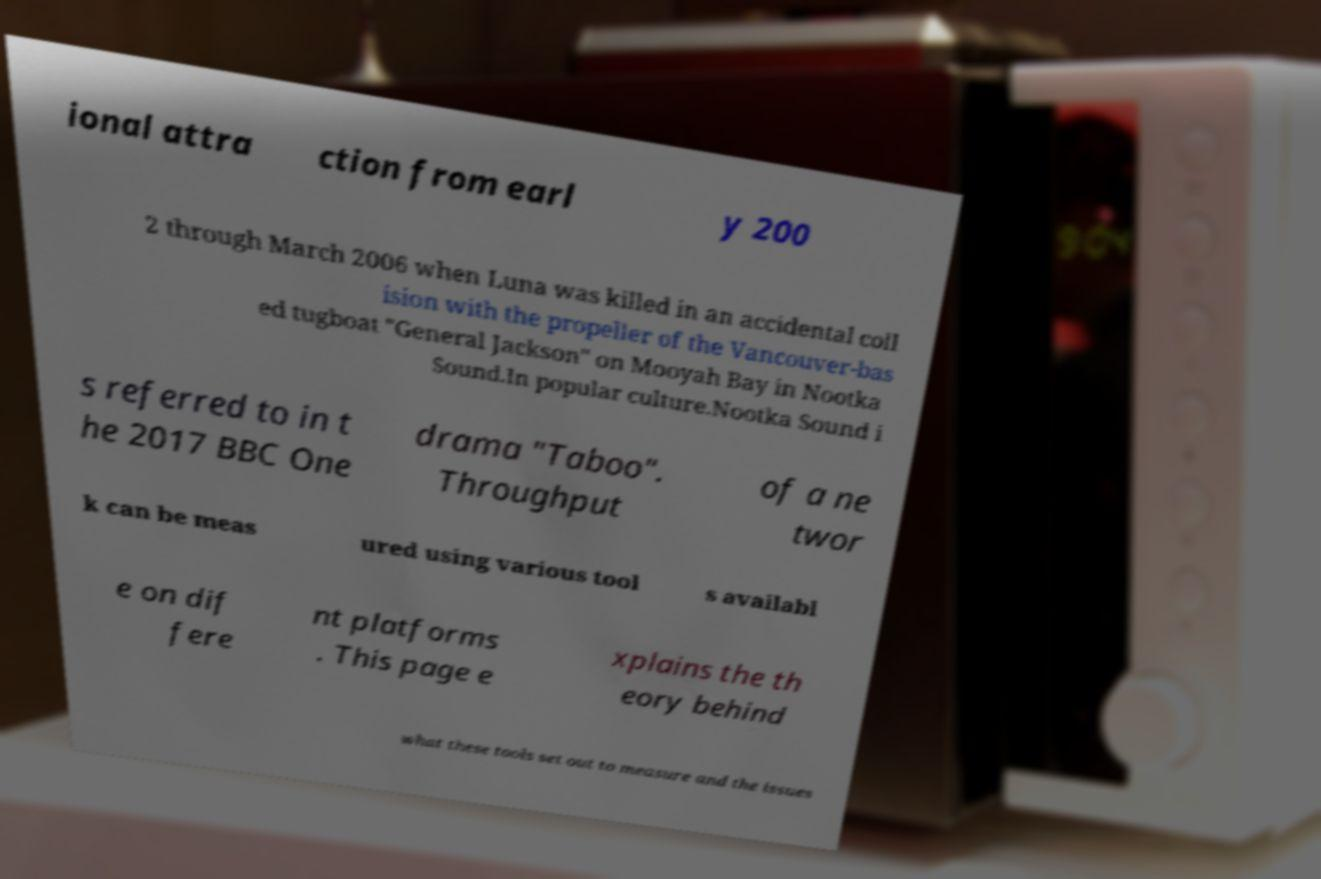Please read and relay the text visible in this image. What does it say? ional attra ction from earl y 200 2 through March 2006 when Luna was killed in an accidental coll ision with the propeller of the Vancouver-bas ed tugboat "General Jackson" on Mooyah Bay in Nootka Sound.In popular culture.Nootka Sound i s referred to in t he 2017 BBC One drama "Taboo". Throughput of a ne twor k can be meas ured using various tool s availabl e on dif fere nt platforms . This page e xplains the th eory behind what these tools set out to measure and the issues 